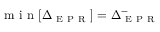Convert formula to latex. <formula><loc_0><loc_0><loc_500><loc_500>m i n [ \Delta _ { E P R } ] = \Delta _ { E P R } ^ { - }</formula> 